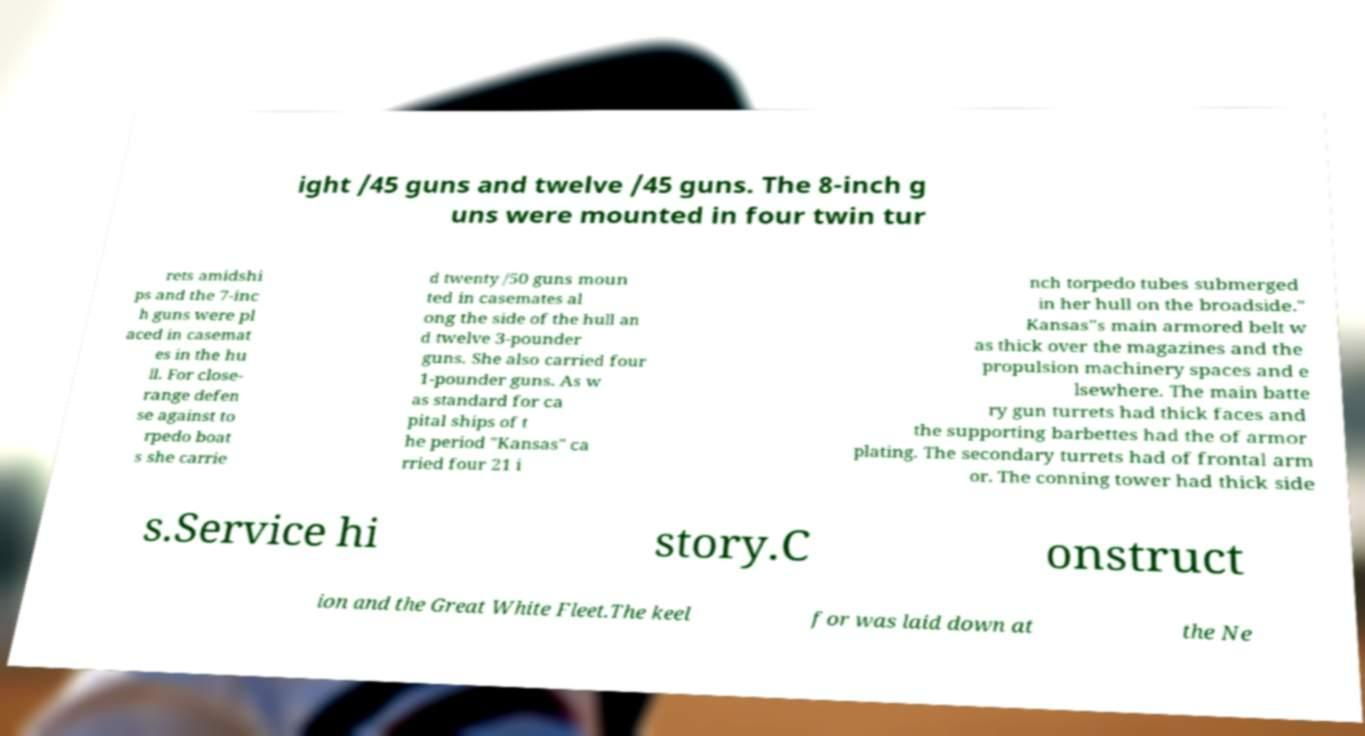Please identify and transcribe the text found in this image. ight /45 guns and twelve /45 guns. The 8-inch g uns were mounted in four twin tur rets amidshi ps and the 7-inc h guns were pl aced in casemat es in the hu ll. For close- range defen se against to rpedo boat s she carrie d twenty /50 guns moun ted in casemates al ong the side of the hull an d twelve 3-pounder guns. She also carried four 1-pounder guns. As w as standard for ca pital ships of t he period "Kansas" ca rried four 21 i nch torpedo tubes submerged in her hull on the broadside." Kansas"s main armored belt w as thick over the magazines and the propulsion machinery spaces and e lsewhere. The main batte ry gun turrets had thick faces and the supporting barbettes had the of armor plating. The secondary turrets had of frontal arm or. The conning tower had thick side s.Service hi story.C onstruct ion and the Great White Fleet.The keel for was laid down at the Ne 